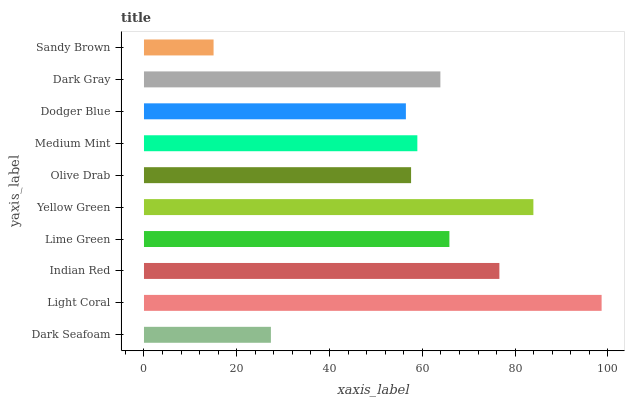Is Sandy Brown the minimum?
Answer yes or no. Yes. Is Light Coral the maximum?
Answer yes or no. Yes. Is Indian Red the minimum?
Answer yes or no. No. Is Indian Red the maximum?
Answer yes or no. No. Is Light Coral greater than Indian Red?
Answer yes or no. Yes. Is Indian Red less than Light Coral?
Answer yes or no. Yes. Is Indian Red greater than Light Coral?
Answer yes or no. No. Is Light Coral less than Indian Red?
Answer yes or no. No. Is Dark Gray the high median?
Answer yes or no. Yes. Is Medium Mint the low median?
Answer yes or no. Yes. Is Light Coral the high median?
Answer yes or no. No. Is Dark Seafoam the low median?
Answer yes or no. No. 